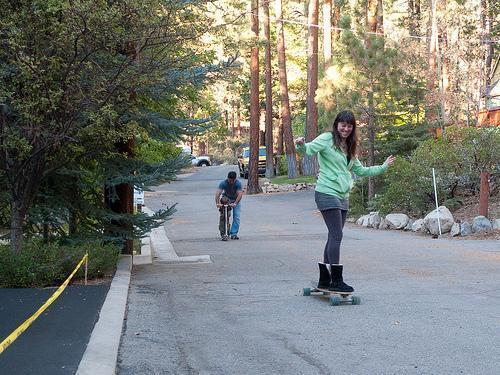How many people are in the picture?
Give a very brief answer. 2. 